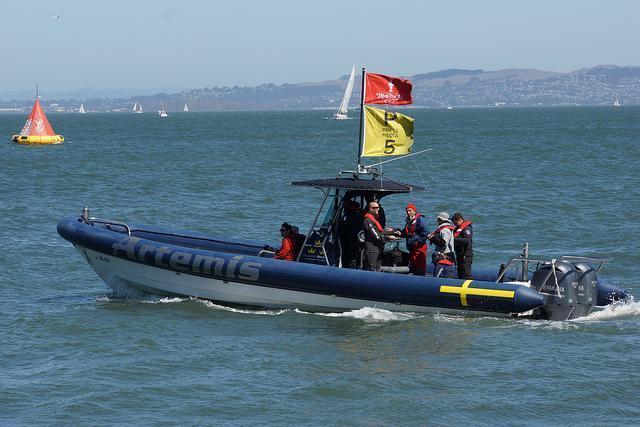How many people are in the picture?
Give a very brief answer. 5. How many boats are visible?
Give a very brief answer. 2. How many doors are on the train car?
Give a very brief answer. 0. 